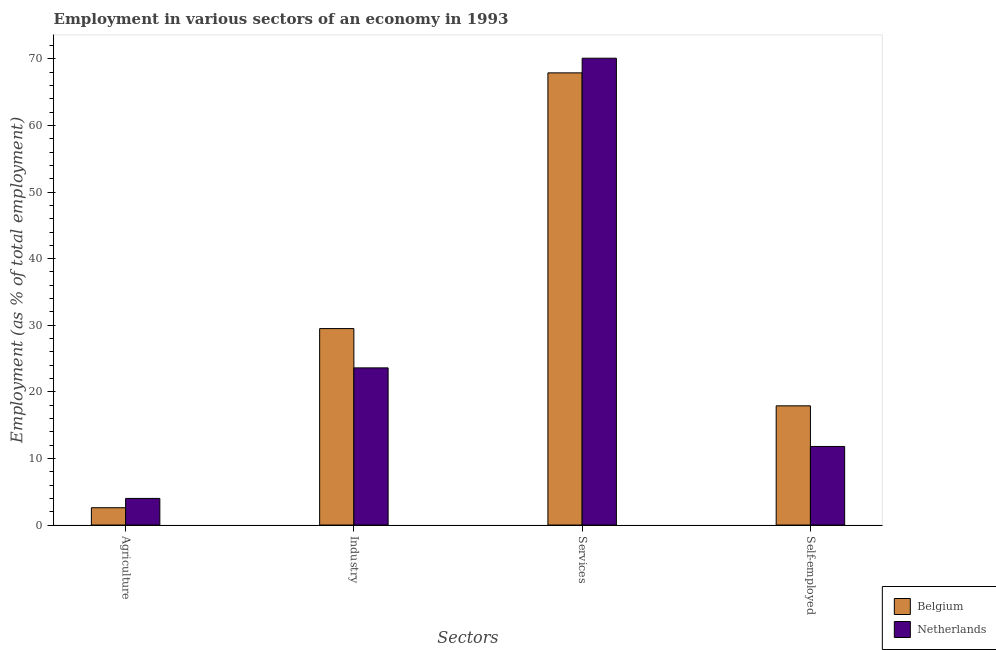How many groups of bars are there?
Your answer should be very brief. 4. Are the number of bars per tick equal to the number of legend labels?
Make the answer very short. Yes. How many bars are there on the 2nd tick from the right?
Your answer should be compact. 2. What is the label of the 1st group of bars from the left?
Ensure brevity in your answer.  Agriculture. What is the percentage of self employed workers in Netherlands?
Provide a succinct answer. 11.8. Across all countries, what is the maximum percentage of workers in industry?
Your answer should be compact. 29.5. Across all countries, what is the minimum percentage of workers in industry?
Offer a very short reply. 23.6. What is the total percentage of workers in agriculture in the graph?
Your answer should be compact. 6.6. What is the difference between the percentage of self employed workers in Netherlands and that in Belgium?
Keep it short and to the point. -6.1. What is the difference between the percentage of workers in services in Belgium and the percentage of workers in agriculture in Netherlands?
Give a very brief answer. 63.9. What is the average percentage of self employed workers per country?
Keep it short and to the point. 14.85. What is the difference between the percentage of self employed workers and percentage of workers in services in Netherlands?
Offer a very short reply. -58.3. What is the ratio of the percentage of workers in industry in Belgium to that in Netherlands?
Make the answer very short. 1.25. Is the percentage of self employed workers in Belgium less than that in Netherlands?
Offer a terse response. No. What is the difference between the highest and the second highest percentage of workers in agriculture?
Offer a terse response. 1.4. What is the difference between the highest and the lowest percentage of self employed workers?
Your response must be concise. 6.1. In how many countries, is the percentage of self employed workers greater than the average percentage of self employed workers taken over all countries?
Your answer should be compact. 1. What does the 1st bar from the left in Services represents?
Your answer should be very brief. Belgium. Is it the case that in every country, the sum of the percentage of workers in agriculture and percentage of workers in industry is greater than the percentage of workers in services?
Your answer should be compact. No. How many bars are there?
Keep it short and to the point. 8. Are all the bars in the graph horizontal?
Keep it short and to the point. No. Are the values on the major ticks of Y-axis written in scientific E-notation?
Provide a succinct answer. No. Does the graph contain any zero values?
Provide a succinct answer. No. Where does the legend appear in the graph?
Offer a terse response. Bottom right. How are the legend labels stacked?
Make the answer very short. Vertical. What is the title of the graph?
Provide a succinct answer. Employment in various sectors of an economy in 1993. What is the label or title of the X-axis?
Offer a very short reply. Sectors. What is the label or title of the Y-axis?
Your answer should be compact. Employment (as % of total employment). What is the Employment (as % of total employment) in Belgium in Agriculture?
Provide a succinct answer. 2.6. What is the Employment (as % of total employment) in Belgium in Industry?
Keep it short and to the point. 29.5. What is the Employment (as % of total employment) in Netherlands in Industry?
Your answer should be very brief. 23.6. What is the Employment (as % of total employment) in Belgium in Services?
Your response must be concise. 67.9. What is the Employment (as % of total employment) in Netherlands in Services?
Keep it short and to the point. 70.1. What is the Employment (as % of total employment) of Belgium in Self-employed?
Your answer should be very brief. 17.9. What is the Employment (as % of total employment) in Netherlands in Self-employed?
Give a very brief answer. 11.8. Across all Sectors, what is the maximum Employment (as % of total employment) of Belgium?
Provide a short and direct response. 67.9. Across all Sectors, what is the maximum Employment (as % of total employment) of Netherlands?
Provide a short and direct response. 70.1. Across all Sectors, what is the minimum Employment (as % of total employment) of Belgium?
Your response must be concise. 2.6. What is the total Employment (as % of total employment) of Belgium in the graph?
Keep it short and to the point. 117.9. What is the total Employment (as % of total employment) in Netherlands in the graph?
Your response must be concise. 109.5. What is the difference between the Employment (as % of total employment) of Belgium in Agriculture and that in Industry?
Your response must be concise. -26.9. What is the difference between the Employment (as % of total employment) in Netherlands in Agriculture and that in Industry?
Ensure brevity in your answer.  -19.6. What is the difference between the Employment (as % of total employment) of Belgium in Agriculture and that in Services?
Make the answer very short. -65.3. What is the difference between the Employment (as % of total employment) of Netherlands in Agriculture and that in Services?
Keep it short and to the point. -66.1. What is the difference between the Employment (as % of total employment) in Belgium in Agriculture and that in Self-employed?
Keep it short and to the point. -15.3. What is the difference between the Employment (as % of total employment) of Netherlands in Agriculture and that in Self-employed?
Provide a succinct answer. -7.8. What is the difference between the Employment (as % of total employment) in Belgium in Industry and that in Services?
Offer a very short reply. -38.4. What is the difference between the Employment (as % of total employment) of Netherlands in Industry and that in Services?
Offer a terse response. -46.5. What is the difference between the Employment (as % of total employment) in Belgium in Industry and that in Self-employed?
Your answer should be compact. 11.6. What is the difference between the Employment (as % of total employment) in Netherlands in Industry and that in Self-employed?
Give a very brief answer. 11.8. What is the difference between the Employment (as % of total employment) of Belgium in Services and that in Self-employed?
Offer a very short reply. 50. What is the difference between the Employment (as % of total employment) of Netherlands in Services and that in Self-employed?
Your answer should be very brief. 58.3. What is the difference between the Employment (as % of total employment) of Belgium in Agriculture and the Employment (as % of total employment) of Netherlands in Industry?
Offer a very short reply. -21. What is the difference between the Employment (as % of total employment) of Belgium in Agriculture and the Employment (as % of total employment) of Netherlands in Services?
Your answer should be compact. -67.5. What is the difference between the Employment (as % of total employment) of Belgium in Industry and the Employment (as % of total employment) of Netherlands in Services?
Provide a succinct answer. -40.6. What is the difference between the Employment (as % of total employment) of Belgium in Services and the Employment (as % of total employment) of Netherlands in Self-employed?
Offer a terse response. 56.1. What is the average Employment (as % of total employment) in Belgium per Sectors?
Make the answer very short. 29.48. What is the average Employment (as % of total employment) of Netherlands per Sectors?
Keep it short and to the point. 27.38. What is the difference between the Employment (as % of total employment) of Belgium and Employment (as % of total employment) of Netherlands in Agriculture?
Give a very brief answer. -1.4. What is the ratio of the Employment (as % of total employment) of Belgium in Agriculture to that in Industry?
Give a very brief answer. 0.09. What is the ratio of the Employment (as % of total employment) of Netherlands in Agriculture to that in Industry?
Offer a terse response. 0.17. What is the ratio of the Employment (as % of total employment) of Belgium in Agriculture to that in Services?
Your answer should be compact. 0.04. What is the ratio of the Employment (as % of total employment) in Netherlands in Agriculture to that in Services?
Your response must be concise. 0.06. What is the ratio of the Employment (as % of total employment) of Belgium in Agriculture to that in Self-employed?
Your answer should be very brief. 0.15. What is the ratio of the Employment (as % of total employment) in Netherlands in Agriculture to that in Self-employed?
Provide a succinct answer. 0.34. What is the ratio of the Employment (as % of total employment) of Belgium in Industry to that in Services?
Make the answer very short. 0.43. What is the ratio of the Employment (as % of total employment) of Netherlands in Industry to that in Services?
Offer a terse response. 0.34. What is the ratio of the Employment (as % of total employment) in Belgium in Industry to that in Self-employed?
Provide a succinct answer. 1.65. What is the ratio of the Employment (as % of total employment) of Belgium in Services to that in Self-employed?
Your answer should be compact. 3.79. What is the ratio of the Employment (as % of total employment) in Netherlands in Services to that in Self-employed?
Offer a very short reply. 5.94. What is the difference between the highest and the second highest Employment (as % of total employment) of Belgium?
Ensure brevity in your answer.  38.4. What is the difference between the highest and the second highest Employment (as % of total employment) of Netherlands?
Provide a succinct answer. 46.5. What is the difference between the highest and the lowest Employment (as % of total employment) in Belgium?
Ensure brevity in your answer.  65.3. What is the difference between the highest and the lowest Employment (as % of total employment) in Netherlands?
Keep it short and to the point. 66.1. 